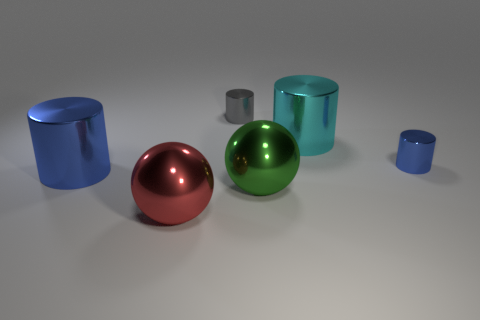How many things are large cylinders that are on the left side of the cyan thing or tiny cylinders that are behind the big green thing?
Offer a terse response. 3. Is the number of big green metal objects that are in front of the green metallic ball less than the number of spheres?
Make the answer very short. Yes. Is there a green object of the same size as the gray thing?
Ensure brevity in your answer.  No. Is the red metal ball the same size as the green shiny object?
Provide a succinct answer. Yes. What number of objects are either small gray metal things or tiny red rubber blocks?
Make the answer very short. 1. Is the number of big green metallic objects left of the large blue metal object the same as the number of big purple objects?
Your response must be concise. Yes. There is a blue cylinder that is on the right side of the big cylinder left of the green metallic sphere; are there any blue metal things left of it?
Ensure brevity in your answer.  Yes. What is the color of the large cylinder that is the same material as the big blue thing?
Ensure brevity in your answer.  Cyan. What number of balls are big red shiny things or small gray shiny things?
Provide a short and direct response. 1. There is a cylinder right of the big metal object that is behind the big metallic cylinder on the left side of the gray metallic object; how big is it?
Provide a short and direct response. Small. 